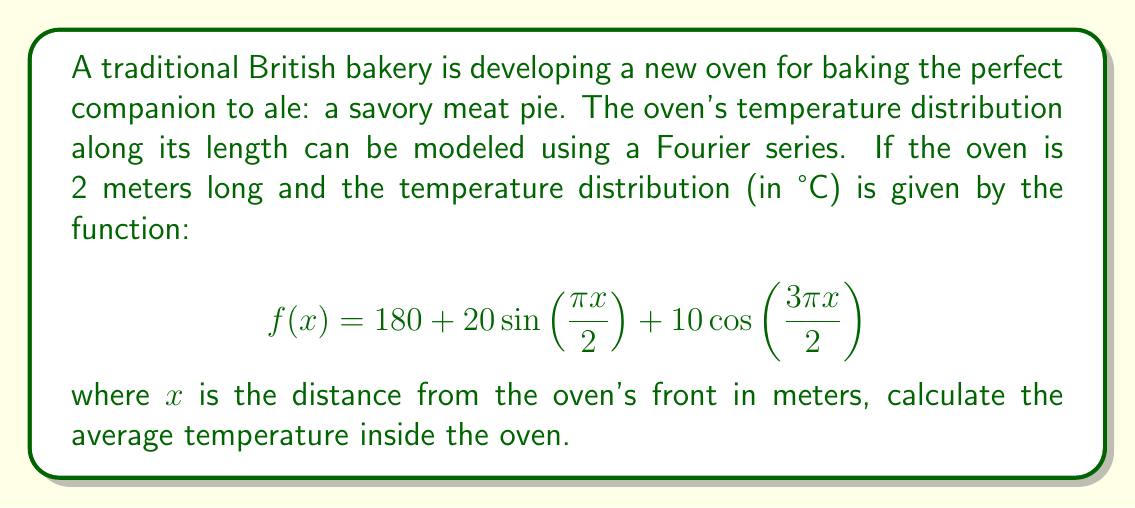Solve this math problem. To find the average temperature inside the oven, we need to integrate the temperature function over the length of the oven and divide by the total length. This is equivalent to finding the mean value of the function over the interval [0, 2].

The formula for the average value of a function $f(x)$ over an interval $[a, b]$ is:

$$\text{Average} = \frac{1}{b-a} \int_a^b f(x) dx$$

In our case, $a = 0$, $b = 2$, and $f(x) = 180 + 20\sin(\frac{\pi x}{2}) + 10\cos(\frac{3\pi x}{2})$

Let's integrate each term separately:

1) $\int_0^2 180 dx = 180x|_0^2 = 360$

2) $\int_0^2 20\sin(\frac{\pi x}{2}) dx = -\frac{40}{\pi}\cos(\frac{\pi x}{2})|_0^2 = -\frac{40}{\pi}[-1 - (-1)] = 0$

3) $\int_0^2 10\cos(\frac{3\pi x}{2}) dx = \frac{20}{3\pi}\sin(\frac{3\pi x}{2})|_0^2 = \frac{20}{3\pi}[0 - 0] = 0$

The total integral is 360.

Now, we divide by the length of the interval (2 meters):

$$\text{Average Temperature} = \frac{360}{2} = 180$$
Answer: The average temperature inside the oven is 180°C. 